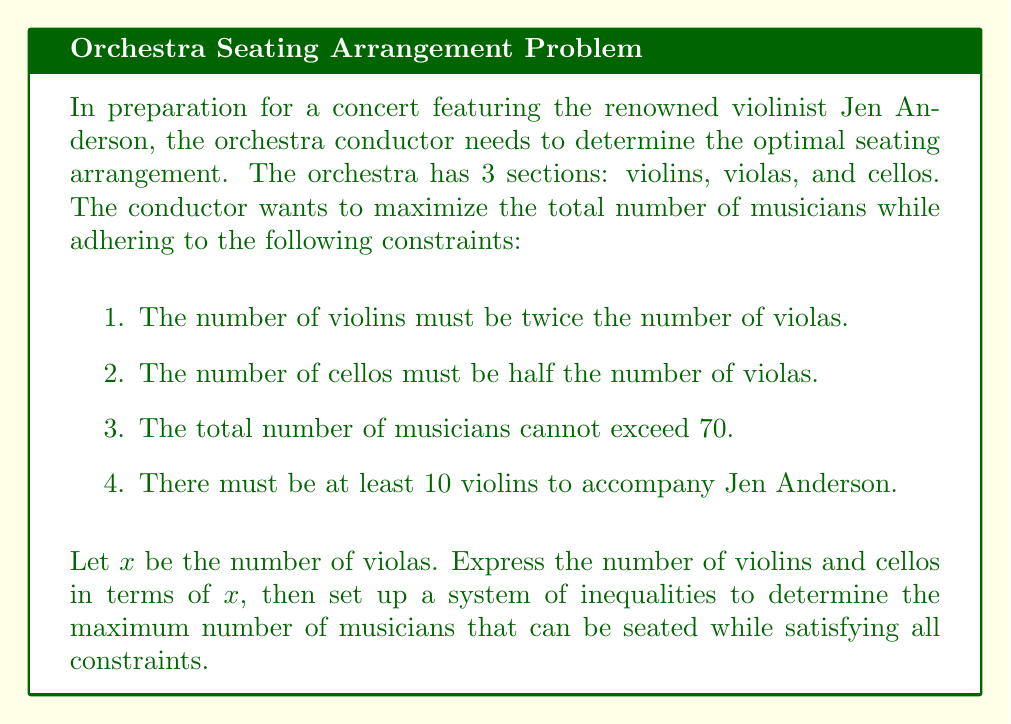Solve this math problem. Let's approach this step-by-step:

1. Define variables:
   $x$ = number of violas
   $2x$ = number of violins (twice the number of violas)
   $\frac{1}{2}x$ = number of cellos (half the number of violas)

2. Set up inequalities based on the constraints:

   a. Total musicians ≤ 70:
      $2x + x + \frac{1}{2}x \leq 70$
      $\frac{7}{2}x \leq 70$

   b. At least 10 violins:
      $2x \geq 10$
      $x \geq 5$

3. Combine inequalities:
   $$\begin{cases}
   \frac{7}{2}x \leq 70 \\
   x \geq 5
   \end{cases}$$

4. Solve the system:
   From $\frac{7}{2}x \leq 70$, we get $x \leq 20$

   Therefore, the solution is $5 \leq x \leq 20$

5. To maximize the total number of musicians, we choose the largest value of $x$, which is 20.

6. Calculate the number of musicians in each section:
   Violas: $x = 20$
   Violins: $2x = 2(20) = 40$
   Cellos: $\frac{1}{2}x = \frac{1}{2}(20) = 10$

7. Total number of musicians:
   $20 + 40 + 10 = 70$

This arrangement satisfies all constraints and maximizes the total number of musicians.
Answer: The optimal seating arrangement is 40 violins, 20 violas, and 10 cellos, for a total of 70 musicians. 